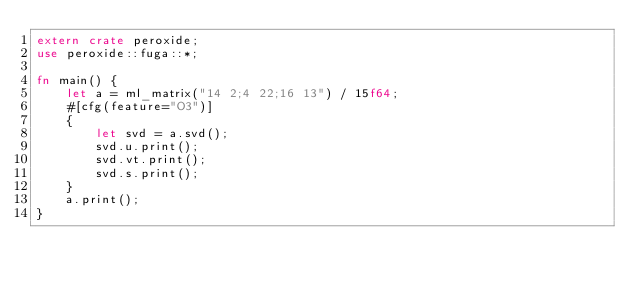<code> <loc_0><loc_0><loc_500><loc_500><_Rust_>extern crate peroxide;
use peroxide::fuga::*;

fn main() {
    let a = ml_matrix("14 2;4 22;16 13") / 15f64;
    #[cfg(feature="O3")]
    {
        let svd = a.svd();
        svd.u.print();
        svd.vt.print();
        svd.s.print();
    }
    a.print();
}
</code> 